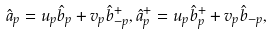<formula> <loc_0><loc_0><loc_500><loc_500>\hat { a } _ { p } = u _ { p } \hat { b } _ { p } + v _ { p } \hat { b } ^ { + } _ { - p } , \hat { a } _ { p } ^ { + } = u _ { p } \hat { b } ^ { + } _ { p } + v _ { p } \hat { b } _ { - p } ,</formula> 